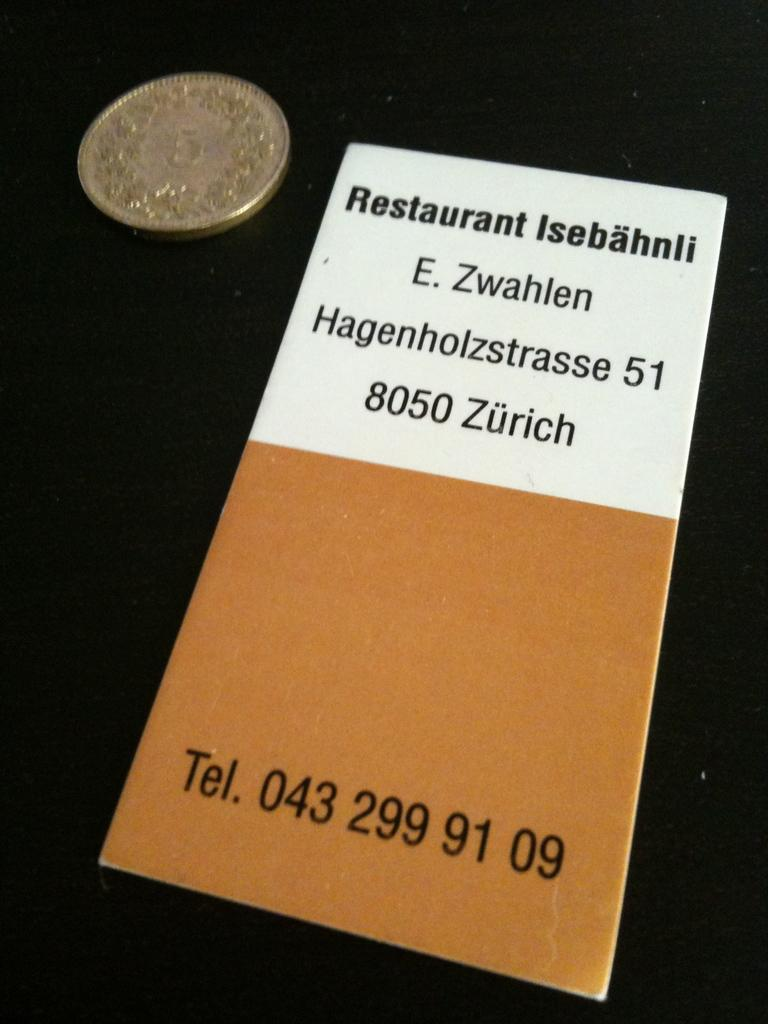<image>
Present a compact description of the photo's key features. Pamphlet on a Restaurant Isebahnli address is E. Zwashlen Hagenholzstrasse 51 8050 Zurich and Telephone number 043 299 91 09. 